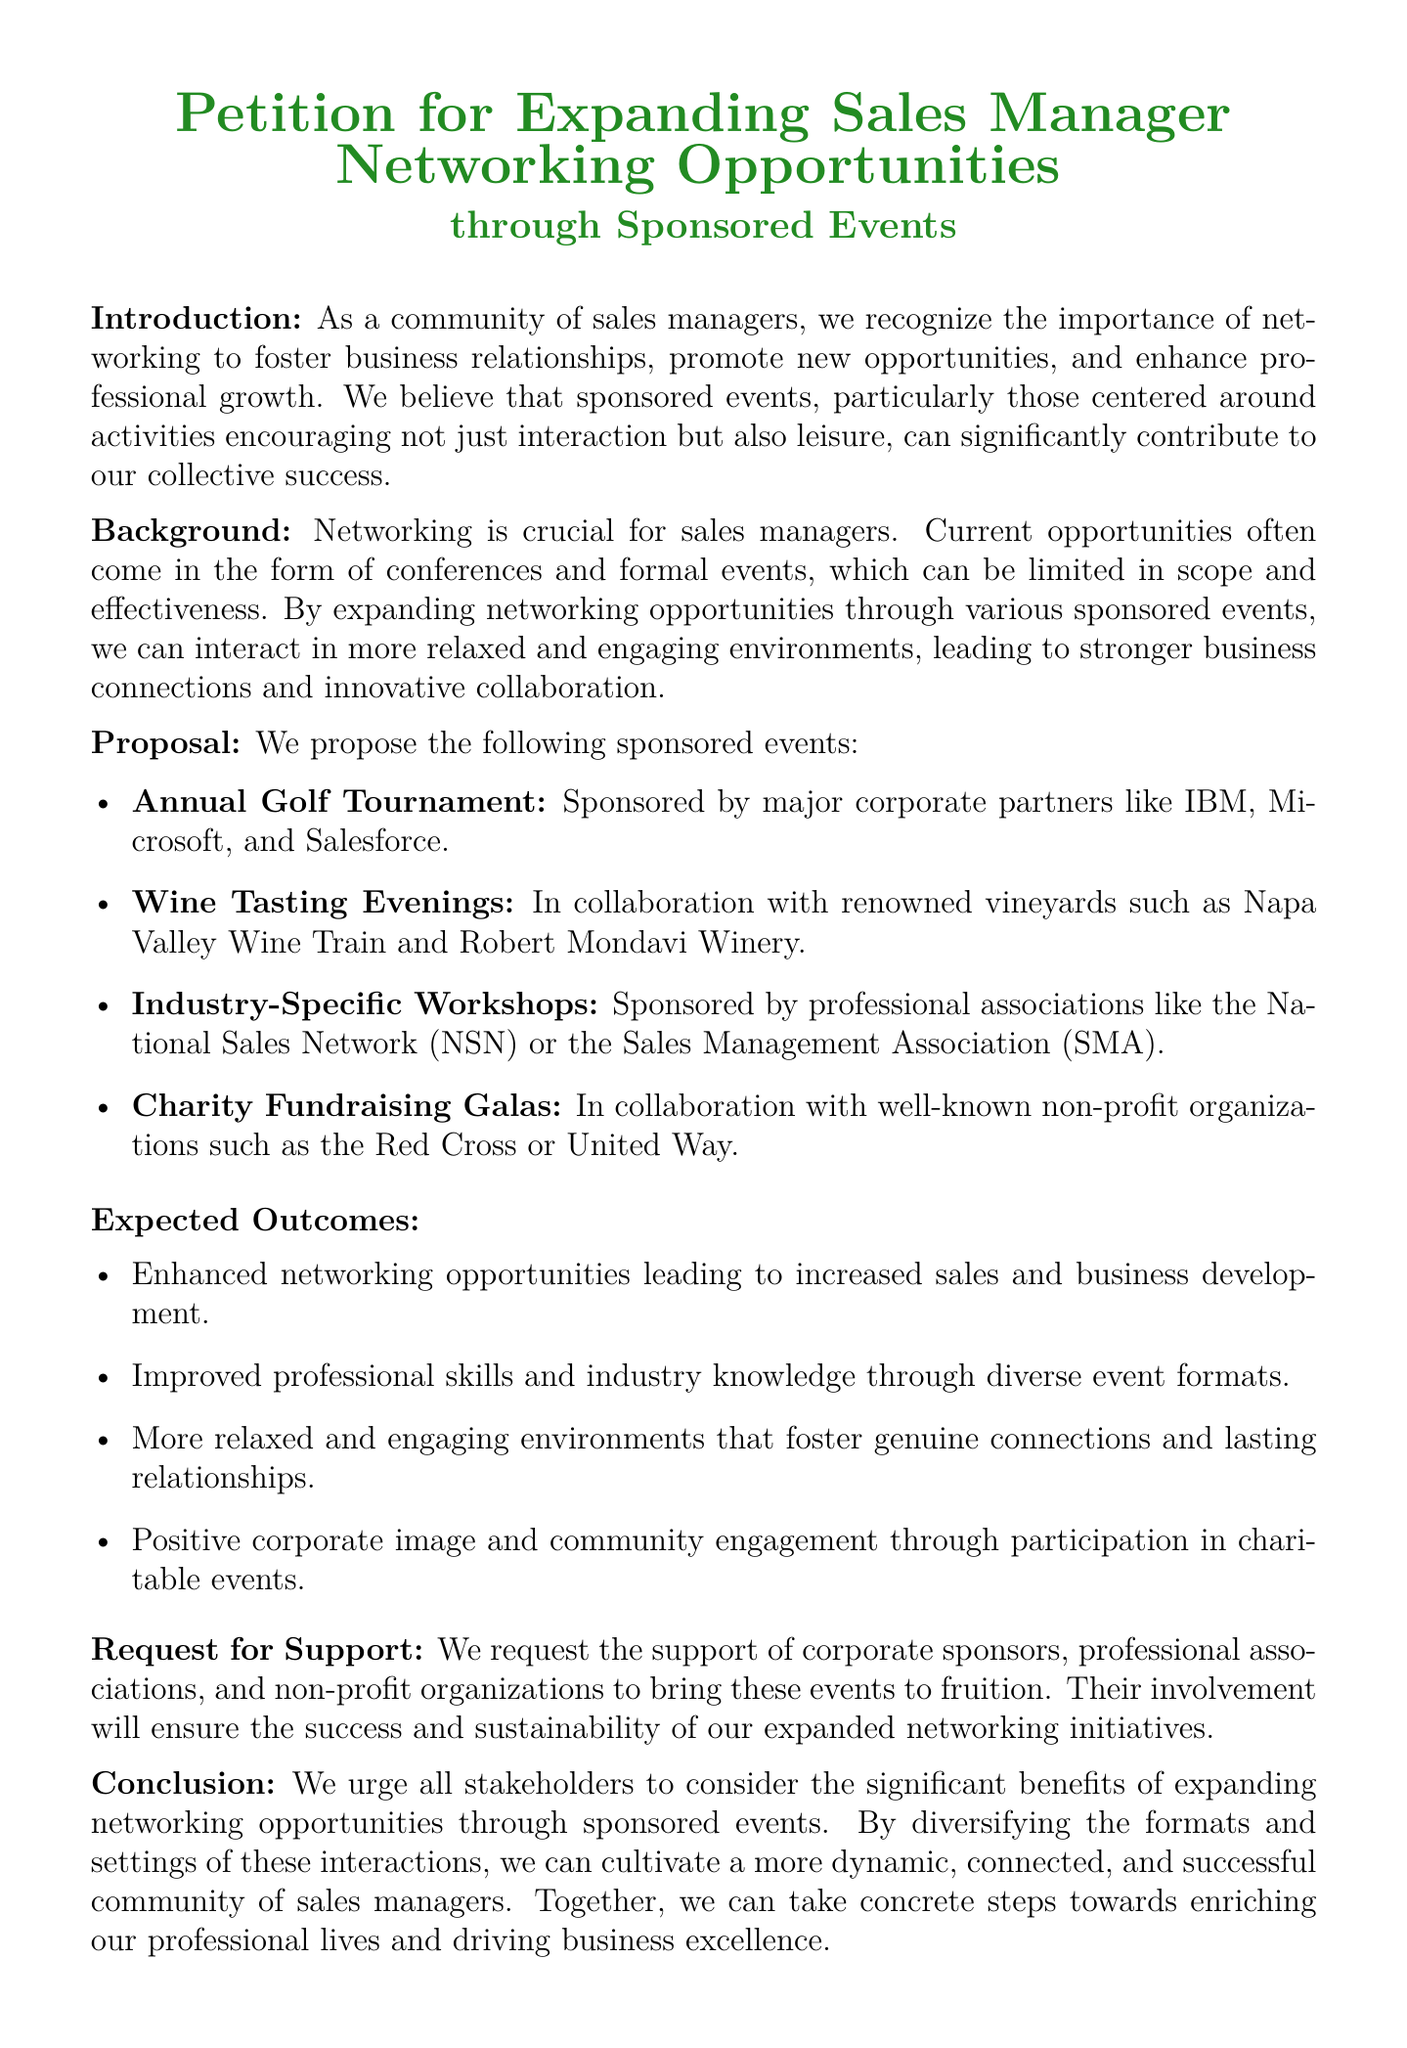What is the title of the petition? The title of the petition can be found prominently at the beginning of the document, which emphasizes the aim of the initiative.
Answer: Petition for Expanding Sales Manager Networking Opportunities What event is proposed for networking? The document lists various events, and the most highlighted one pertains to a widely recognized networking activity.
Answer: Annual Golf Tournament Who are the sponsors proposed for the golf tournament? The document mentions major corporate partners that are envisioned to sponsor the event, which indicates their significance.
Answer: IBM, Microsoft, and Salesforce What are the expected outcomes of these events? The document lists multiple expected benefits of conducting the proposed events, providing insight into their potential impact.
Answer: Enhanced networking opportunities What type of event is paired with charity work? The proposal specifically includes events aimed at giving back to the community, fostering social responsibility alongside networking.
Answer: Charity Fundraising Galas Which organization is mentioned in collaboration with wine tasting evenings? The document highlights a specific vineyard that is believed to be associated with one of the proposed events.
Answer: Robert Mondavi Winery What does the petition request from corporate sponsors? The core ask of the petition emphasizes the requirement of support from various entities, expressing a need for collaboration.
Answer: Support How does the petition suggest enhancing professional skills? The document implies the use of an event format that is unique and diverse to aid in professional development among sales managers.
Answer: Industry-Specific Workshops 